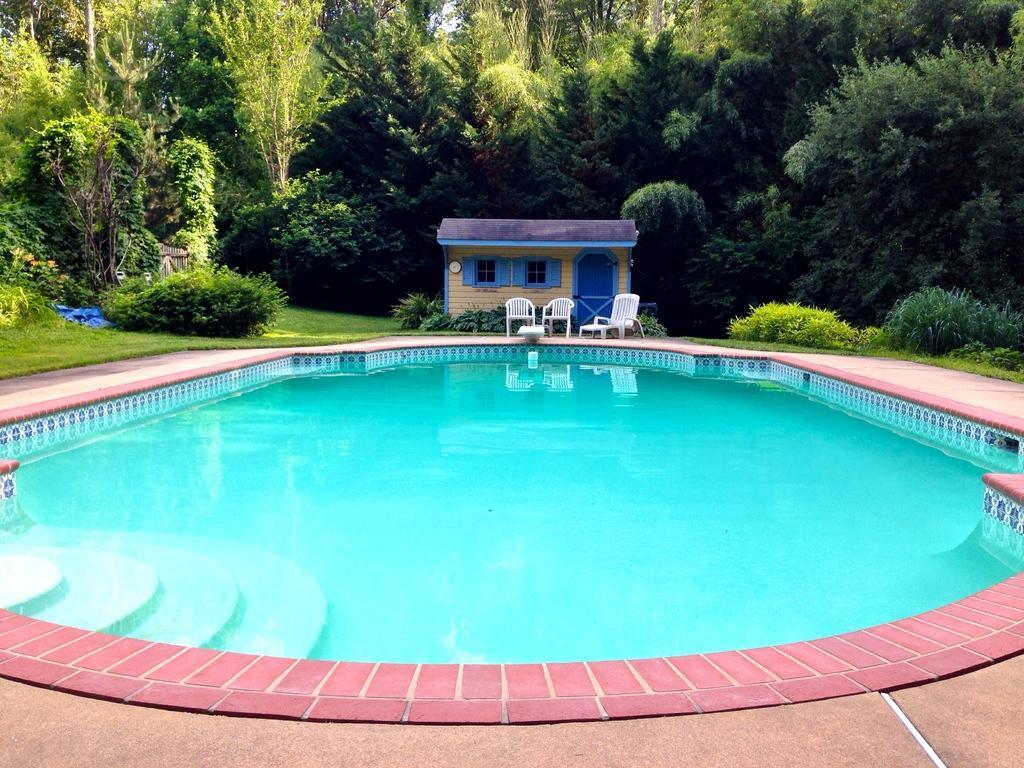Can you describe this image briefly? In the picture i can see swimming pool in which there is water, in the background of the picture there are some chairs, house and there are some trees. 